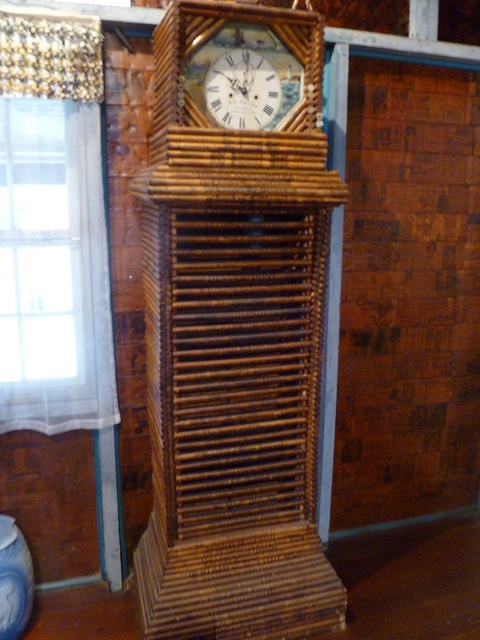Describe the objects in this image and their specific colors. I can see a clock in lightgray, maroon, gray, and brown tones in this image. 